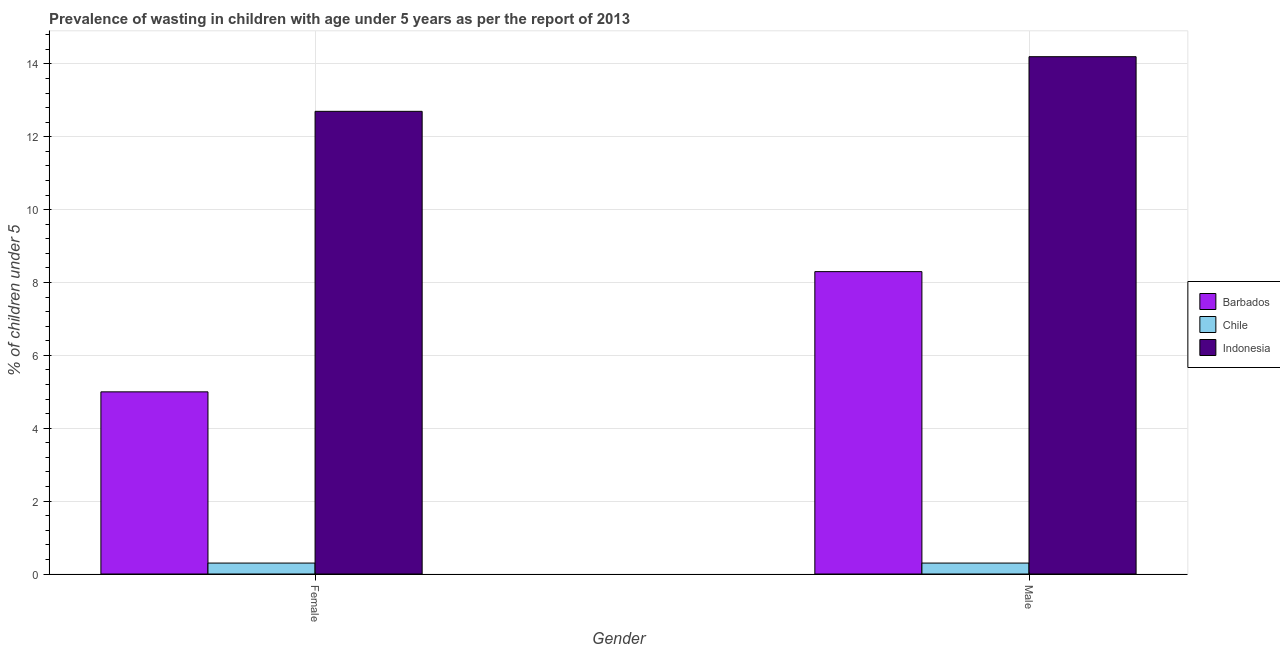Are the number of bars on each tick of the X-axis equal?
Give a very brief answer. Yes. How many bars are there on the 2nd tick from the right?
Provide a short and direct response. 3. What is the percentage of undernourished female children in Chile?
Ensure brevity in your answer.  0.3. Across all countries, what is the maximum percentage of undernourished female children?
Offer a very short reply. 12.7. Across all countries, what is the minimum percentage of undernourished female children?
Give a very brief answer. 0.3. What is the total percentage of undernourished female children in the graph?
Give a very brief answer. 18. What is the difference between the percentage of undernourished male children in Indonesia and that in Barbados?
Offer a very short reply. 5.9. What is the difference between the percentage of undernourished male children in Barbados and the percentage of undernourished female children in Indonesia?
Offer a very short reply. -4.4. What is the average percentage of undernourished female children per country?
Give a very brief answer. 6. In how many countries, is the percentage of undernourished female children greater than 5.2 %?
Your answer should be very brief. 1. What is the ratio of the percentage of undernourished female children in Barbados to that in Indonesia?
Ensure brevity in your answer.  0.39. In how many countries, is the percentage of undernourished male children greater than the average percentage of undernourished male children taken over all countries?
Your response must be concise. 2. How many bars are there?
Give a very brief answer. 6. How many countries are there in the graph?
Provide a succinct answer. 3. Does the graph contain any zero values?
Provide a short and direct response. No. Where does the legend appear in the graph?
Give a very brief answer. Center right. How are the legend labels stacked?
Make the answer very short. Vertical. What is the title of the graph?
Make the answer very short. Prevalence of wasting in children with age under 5 years as per the report of 2013. Does "Middle East & North Africa (developing only)" appear as one of the legend labels in the graph?
Offer a very short reply. No. What is the label or title of the X-axis?
Your response must be concise. Gender. What is the label or title of the Y-axis?
Your response must be concise.  % of children under 5. What is the  % of children under 5 in Chile in Female?
Provide a short and direct response. 0.3. What is the  % of children under 5 of Indonesia in Female?
Provide a succinct answer. 12.7. What is the  % of children under 5 in Chile in Male?
Provide a short and direct response. 0.3. What is the  % of children under 5 in Indonesia in Male?
Your answer should be very brief. 14.2. Across all Gender, what is the maximum  % of children under 5 of Chile?
Keep it short and to the point. 0.3. Across all Gender, what is the maximum  % of children under 5 of Indonesia?
Ensure brevity in your answer.  14.2. Across all Gender, what is the minimum  % of children under 5 of Chile?
Provide a succinct answer. 0.3. Across all Gender, what is the minimum  % of children under 5 of Indonesia?
Make the answer very short. 12.7. What is the total  % of children under 5 in Barbados in the graph?
Offer a terse response. 13.3. What is the total  % of children under 5 in Chile in the graph?
Make the answer very short. 0.6. What is the total  % of children under 5 of Indonesia in the graph?
Keep it short and to the point. 26.9. What is the difference between the  % of children under 5 in Barbados in Female and that in Male?
Make the answer very short. -3.3. What is the difference between the  % of children under 5 of Chile in Female and the  % of children under 5 of Indonesia in Male?
Keep it short and to the point. -13.9. What is the average  % of children under 5 in Barbados per Gender?
Offer a terse response. 6.65. What is the average  % of children under 5 in Chile per Gender?
Make the answer very short. 0.3. What is the average  % of children under 5 of Indonesia per Gender?
Your response must be concise. 13.45. What is the difference between the  % of children under 5 of Barbados and  % of children under 5 of Indonesia in Female?
Offer a very short reply. -7.7. What is the difference between the  % of children under 5 of Barbados and  % of children under 5 of Chile in Male?
Offer a terse response. 8. What is the ratio of the  % of children under 5 in Barbados in Female to that in Male?
Give a very brief answer. 0.6. What is the ratio of the  % of children under 5 of Chile in Female to that in Male?
Provide a short and direct response. 1. What is the ratio of the  % of children under 5 in Indonesia in Female to that in Male?
Your answer should be very brief. 0.89. What is the difference between the highest and the second highest  % of children under 5 in Indonesia?
Your answer should be very brief. 1.5. What is the difference between the highest and the lowest  % of children under 5 in Indonesia?
Offer a very short reply. 1.5. 